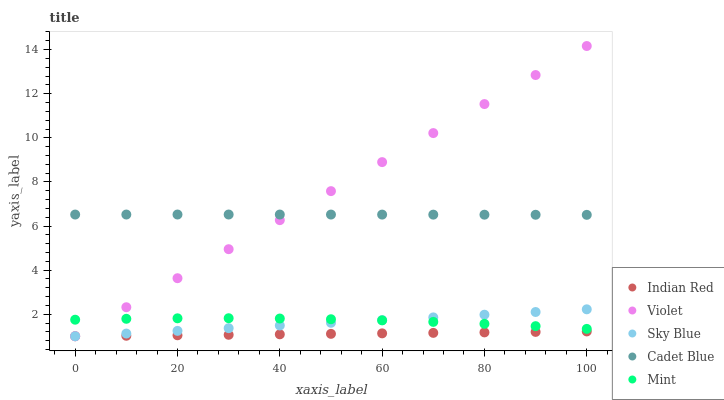Does Indian Red have the minimum area under the curve?
Answer yes or no. Yes. Does Violet have the maximum area under the curve?
Answer yes or no. Yes. Does Cadet Blue have the minimum area under the curve?
Answer yes or no. No. Does Cadet Blue have the maximum area under the curve?
Answer yes or no. No. Is Indian Red the smoothest?
Answer yes or no. Yes. Is Mint the roughest?
Answer yes or no. Yes. Is Cadet Blue the smoothest?
Answer yes or no. No. Is Cadet Blue the roughest?
Answer yes or no. No. Does Sky Blue have the lowest value?
Answer yes or no. Yes. Does Mint have the lowest value?
Answer yes or no. No. Does Violet have the highest value?
Answer yes or no. Yes. Does Cadet Blue have the highest value?
Answer yes or no. No. Is Mint less than Cadet Blue?
Answer yes or no. Yes. Is Cadet Blue greater than Mint?
Answer yes or no. Yes. Does Mint intersect Sky Blue?
Answer yes or no. Yes. Is Mint less than Sky Blue?
Answer yes or no. No. Is Mint greater than Sky Blue?
Answer yes or no. No. Does Mint intersect Cadet Blue?
Answer yes or no. No. 